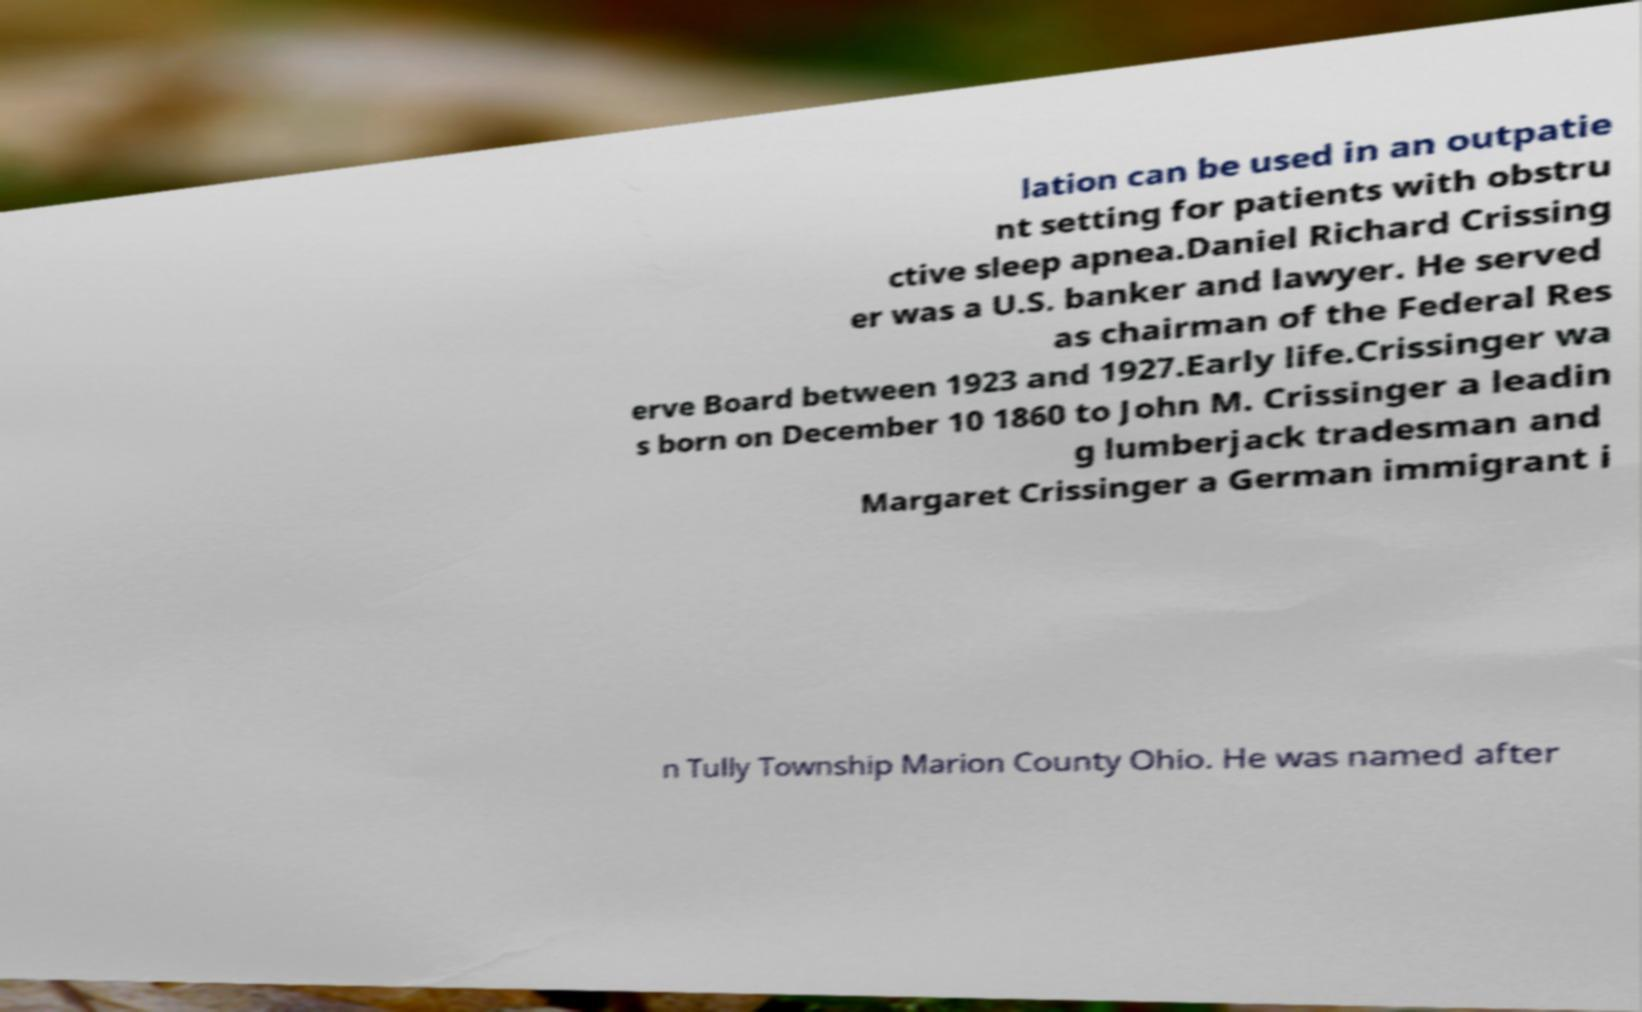There's text embedded in this image that I need extracted. Can you transcribe it verbatim? lation can be used in an outpatie nt setting for patients with obstru ctive sleep apnea.Daniel Richard Crissing er was a U.S. banker and lawyer. He served as chairman of the Federal Res erve Board between 1923 and 1927.Early life.Crissinger wa s born on December 10 1860 to John M. Crissinger a leadin g lumberjack tradesman and Margaret Crissinger a German immigrant i n Tully Township Marion County Ohio. He was named after 